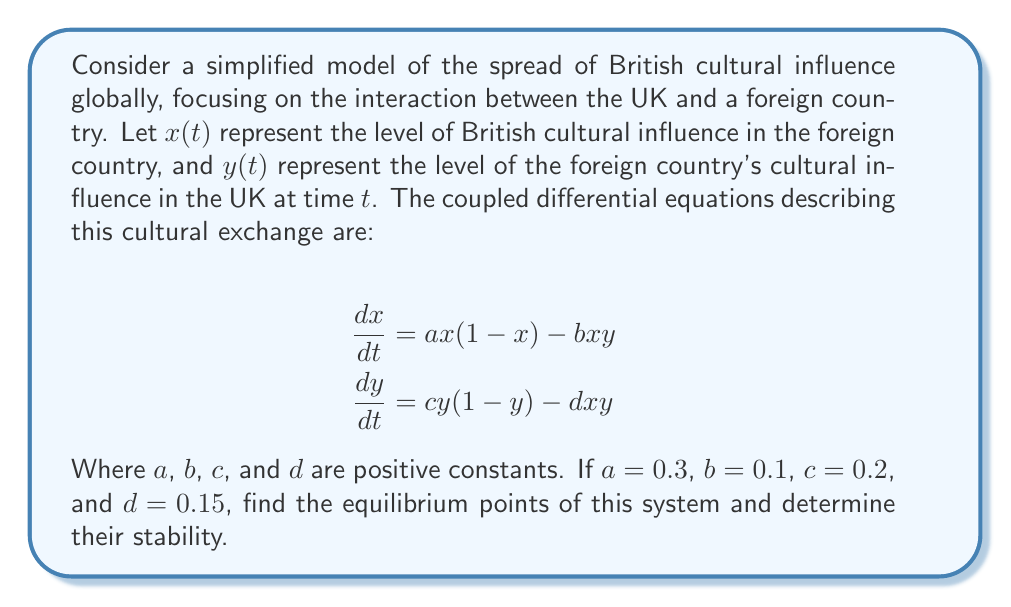What is the answer to this math problem? To solve this problem, we'll follow these steps:

1) Find the equilibrium points by setting both equations equal to zero and solving for $x$ and $y$.

2) Evaluate the Jacobian matrix at each equilibrium point.

3) Determine the stability of each equilibrium point based on the eigenvalues of the Jacobian matrix.

Step 1: Finding equilibrium points

Set both equations to zero:

$$0 = ax(1-x) - bxy = 0.3x(1-x) - 0.1xy$$
$$0 = cy(1-y) - dxy = 0.2y(1-y) - 0.15xy$$

From these equations, we can see that $(0,0)$ is always an equilibrium point. For other points:

From the first equation:
$$x = 0 \text{ or } 0.3(1-x) - 0.1y = 0$$

From the second equation:
$$y = 0 \text{ or } 0.2(1-y) - 0.15x = 0$$

Solving these simultaneously gives us four equilibrium points:
$(0,0)$, $(1,0)$, $(0,1)$, and $(0.6,0.8)$

Step 2: Evaluating the Jacobian matrix

The Jacobian matrix is:

$$J = \begin{bmatrix}
\frac{\partial}{\partial x}(ax(1-x) - bxy) & \frac{\partial}{\partial y}(ax(1-x) - bxy) \\
\frac{\partial}{\partial x}(cy(1-y) - dxy) & \frac{\partial}{\partial y}(cy(1-y) - dxy)
\end{bmatrix}$$

$$J = \begin{bmatrix}
a(1-2x) - by & -bx \\
-dy & c(1-2y) - dx
\end{bmatrix}$$

Step 3: Determining stability

For $(0,0)$:
$$J_{(0,0)} = \begin{bmatrix}
0.3 & 0 \\
0 & 0.2
\end{bmatrix}$$

Eigenvalues are 0.3 and 0.2, both positive. This point is unstable.

For $(1,0)$:
$$J_{(1,0)} = \begin{bmatrix}
-0.3 & -0.1 \\
0 & 0.05
\end{bmatrix}$$

Eigenvalues are -0.3 and 0.05. This point is a saddle point (unstable).

For $(0,1)$:
$$J_{(0,1)} = \begin{bmatrix}
0.2 & 0 \\
-0.15 & -0.2
\end{bmatrix}$$

Eigenvalues are 0.2 and -0.2. This point is also a saddle point (unstable).

For $(0.6,0.8)$:
$$J_{(0.6,0.8)} = \begin{bmatrix}
-0.18 & -0.06 \\
-0.12 & -0.16
\end{bmatrix}$$

The eigenvalues are approximately -0.0781 and -0.2619, both negative. This point is stable.
Answer: Equilibrium points: $(0,0)$, $(1,0)$, $(0,1)$, $(0.6,0.8)$. $(0,0)$, $(1,0)$, $(0,1)$ are unstable; $(0.6,0.8)$ is stable. 